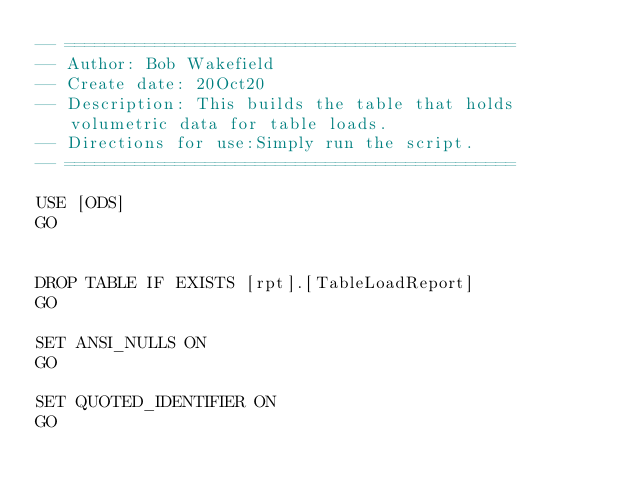<code> <loc_0><loc_0><loc_500><loc_500><_SQL_>-- =============================================
-- Author: Bob Wakefield
-- Create date: 20Oct20
-- Description: This builds the table that holds volumetric data for table loads.
-- Directions for use:Simply run the script.
-- =============================================

USE [ODS]
GO


DROP TABLE IF EXISTS [rpt].[TableLoadReport]
GO

SET ANSI_NULLS ON
GO

SET QUOTED_IDENTIFIER ON
GO
</code> 